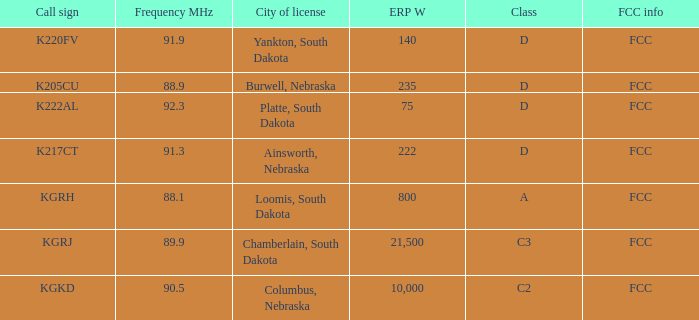What is the average frequency mhz of the loomis, south dakota city license? 88.1. 